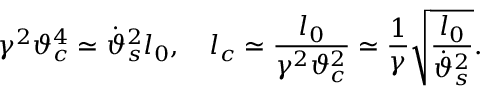Convert formula to latex. <formula><loc_0><loc_0><loc_500><loc_500>\gamma ^ { 2 } \vartheta _ { c } ^ { 4 } \simeq \dot { \vartheta } _ { s } ^ { 2 } l _ { 0 } , \quad l _ { c } \simeq \frac { l _ { 0 } } { \gamma ^ { 2 } \vartheta _ { c } ^ { 2 } } \simeq \frac { 1 } { \gamma } \sqrt { \frac { l _ { 0 } } { \dot { \vartheta } _ { s } ^ { 2 } } } .</formula> 